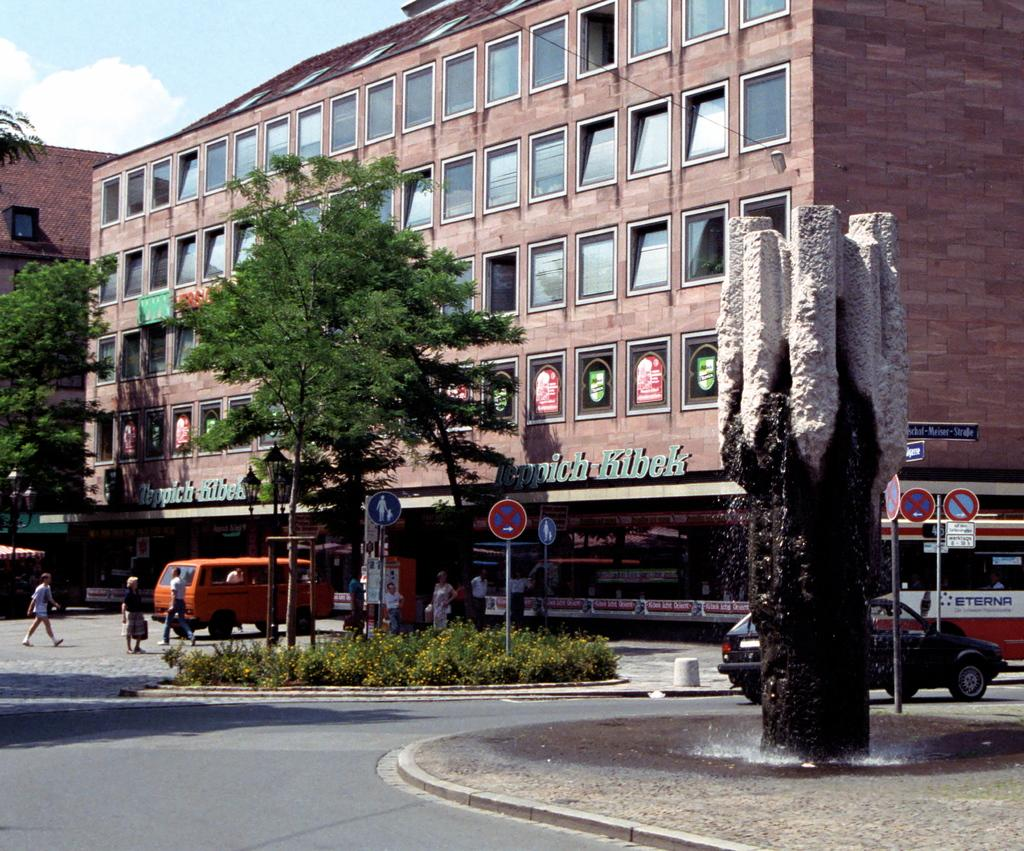What type of natural element is present in the image? There is a tree in the image. What man-made objects can be seen in the image? There are sign boards, vehicles, and buildings in the image. Are there any human subjects in the image? Yes, there are people in the image. Can you see any rub or thread on the seashore in the image? There is no seashore present in the image, so it is not possible to determine if there is any rub or thread on it. 